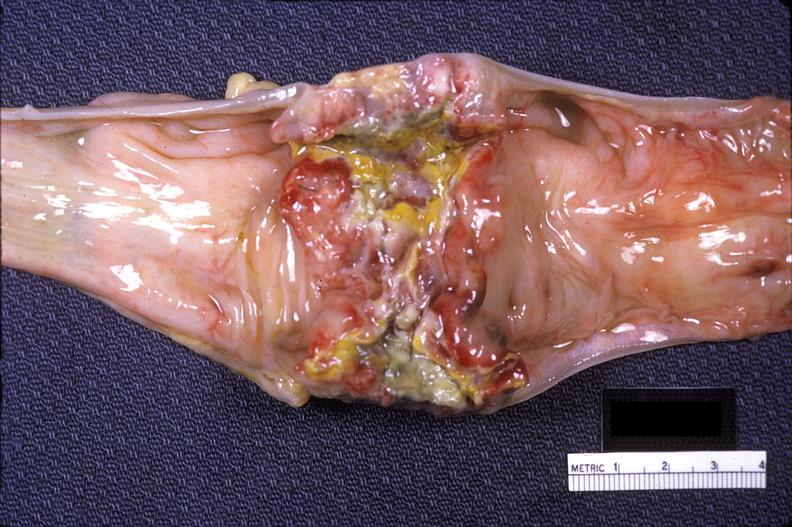s optic nerve present?
Answer the question using a single word or phrase. No 